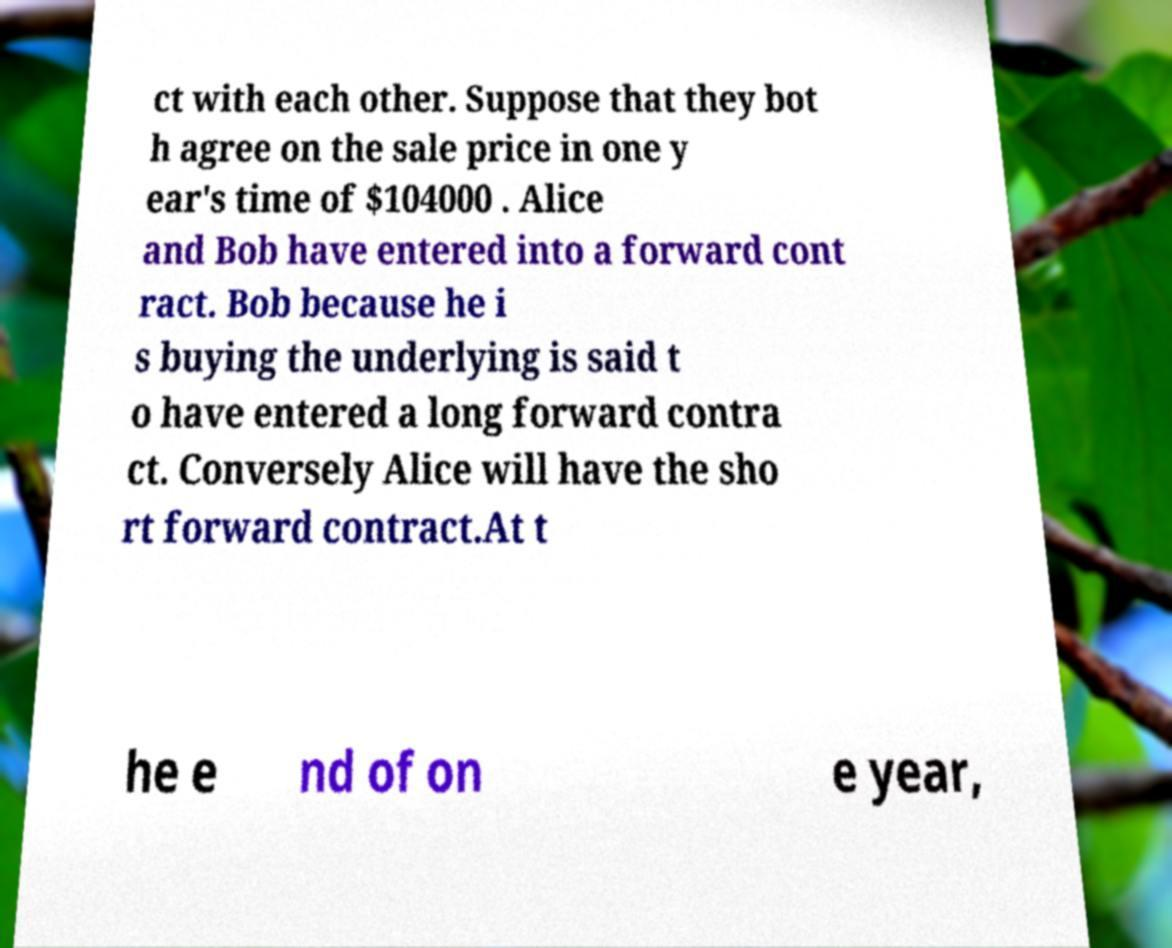I need the written content from this picture converted into text. Can you do that? ct with each other. Suppose that they bot h agree on the sale price in one y ear's time of $104000 . Alice and Bob have entered into a forward cont ract. Bob because he i s buying the underlying is said t o have entered a long forward contra ct. Conversely Alice will have the sho rt forward contract.At t he e nd of on e year, 